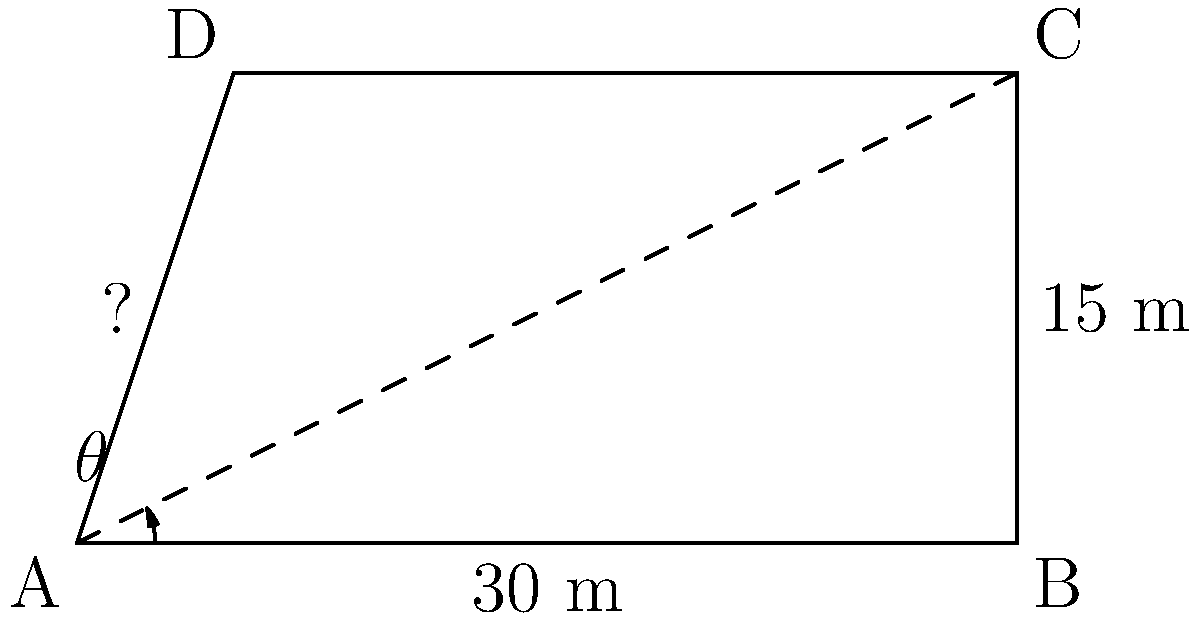During an archaeological excavation, you discover an ancient obelisk. To determine its height without climbing it, you measure its shadow at noon. The shadow extends 30 meters from the base of the obelisk, and the angle of elevation from the tip of the shadow to the top of the obelisk is measured to be 26.6°. Using trigonometric ratios, calculate the height of the obelisk to the nearest meter. Let's approach this step-by-step:

1) First, we need to identify the trigonometric ratio that relates the height of the obelisk to the length of its shadow.

2) In this case, we have:
   - The adjacent side (shadow length) = 30 meters
   - The angle of elevation = 26.6°
   - We need to find the opposite side (height of the obelisk)

3) This scenario calls for the tangent ratio:

   $\tan \theta = \frac{\text{opposite}}{\text{adjacent}} = \frac{\text{height}}{\text{shadow length}}$

4) We can express this as an equation:

   $\tan 26.6° = \frac{\text{height}}{30}$

5) To solve for the height, we multiply both sides by 30:

   $30 \cdot \tan 26.6° = \text{height}$

6) Now, let's calculate:
   
   $\text{height} = 30 \cdot \tan 26.6°$
   
   $\text{height} = 30 \cdot 0.5008$
   
   $\text{height} = 15.024$ meters

7) Rounding to the nearest meter:

   $\text{height} \approx 15$ meters

Thus, the height of the ancient obelisk is approximately 15 meters.
Answer: 15 meters 